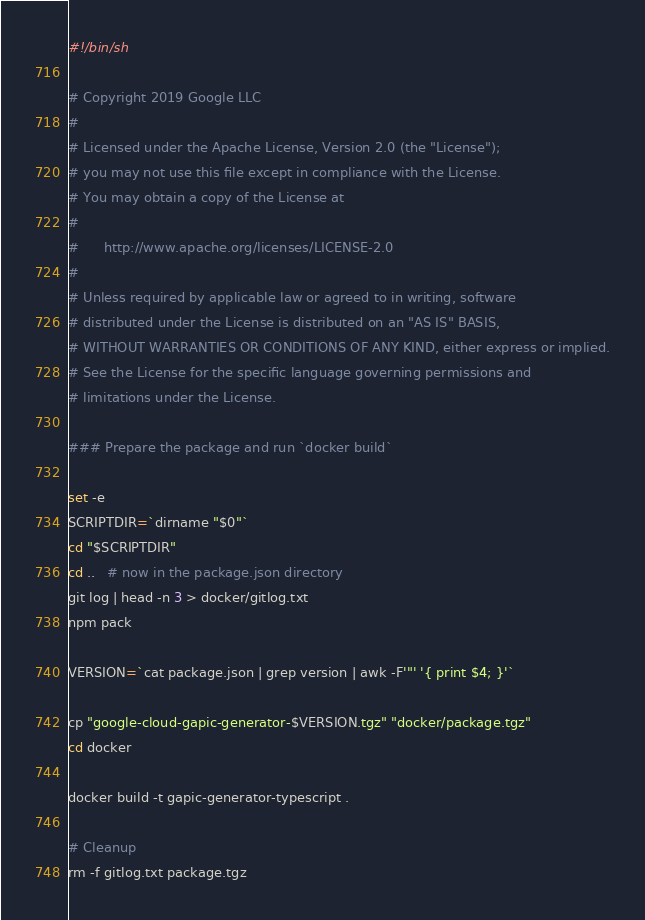Convert code to text. <code><loc_0><loc_0><loc_500><loc_500><_Bash_>#!/bin/sh

# Copyright 2019 Google LLC
#
# Licensed under the Apache License, Version 2.0 (the "License");
# you may not use this file except in compliance with the License.
# You may obtain a copy of the License at
#
#      http://www.apache.org/licenses/LICENSE-2.0
#
# Unless required by applicable law or agreed to in writing, software
# distributed under the License is distributed on an "AS IS" BASIS,
# WITHOUT WARRANTIES OR CONDITIONS OF ANY KIND, either express or implied.
# See the License for the specific language governing permissions and
# limitations under the License.

### Prepare the package and run `docker build`

set -e
SCRIPTDIR=`dirname "$0"`
cd "$SCRIPTDIR"
cd ..   # now in the package.json directory
git log | head -n 3 > docker/gitlog.txt
npm pack

VERSION=`cat package.json | grep version | awk -F'"' '{ print $4; }'`

cp "google-cloud-gapic-generator-$VERSION.tgz" "docker/package.tgz"
cd docker

docker build -t gapic-generator-typescript .

# Cleanup
rm -f gitlog.txt package.tgz
</code> 